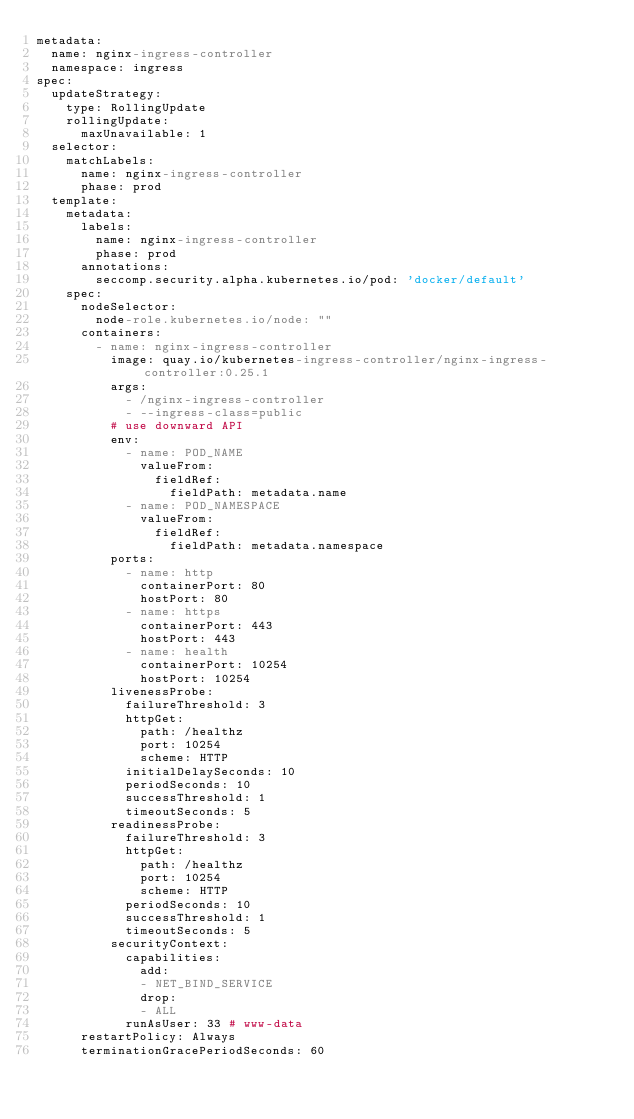Convert code to text. <code><loc_0><loc_0><loc_500><loc_500><_YAML_>metadata:
  name: nginx-ingress-controller
  namespace: ingress
spec:
  updateStrategy:
    type: RollingUpdate
    rollingUpdate:
      maxUnavailable: 1
  selector:
    matchLabels:
      name: nginx-ingress-controller
      phase: prod
  template:
    metadata:
      labels:
        name: nginx-ingress-controller
        phase: prod
      annotations:
        seccomp.security.alpha.kubernetes.io/pod: 'docker/default'
    spec:
      nodeSelector:
        node-role.kubernetes.io/node: ""
      containers:
        - name: nginx-ingress-controller
          image: quay.io/kubernetes-ingress-controller/nginx-ingress-controller:0.25.1
          args:
            - /nginx-ingress-controller
            - --ingress-class=public
          # use downward API
          env:
            - name: POD_NAME
              valueFrom:
                fieldRef:
                  fieldPath: metadata.name
            - name: POD_NAMESPACE
              valueFrom:
                fieldRef:
                  fieldPath: metadata.namespace
          ports:
            - name: http
              containerPort: 80
              hostPort: 80
            - name: https
              containerPort: 443
              hostPort: 443
            - name: health
              containerPort: 10254
              hostPort: 10254
          livenessProbe:
            failureThreshold: 3
            httpGet:
              path: /healthz
              port: 10254
              scheme: HTTP
            initialDelaySeconds: 10
            periodSeconds: 10
            successThreshold: 1
            timeoutSeconds: 5
          readinessProbe:
            failureThreshold: 3
            httpGet:
              path: /healthz
              port: 10254
              scheme: HTTP
            periodSeconds: 10
            successThreshold: 1
            timeoutSeconds: 5
          securityContext:
            capabilities:
              add:
              - NET_BIND_SERVICE
              drop:
              - ALL
            runAsUser: 33 # www-data
      restartPolicy: Always
      terminationGracePeriodSeconds: 60
</code> 